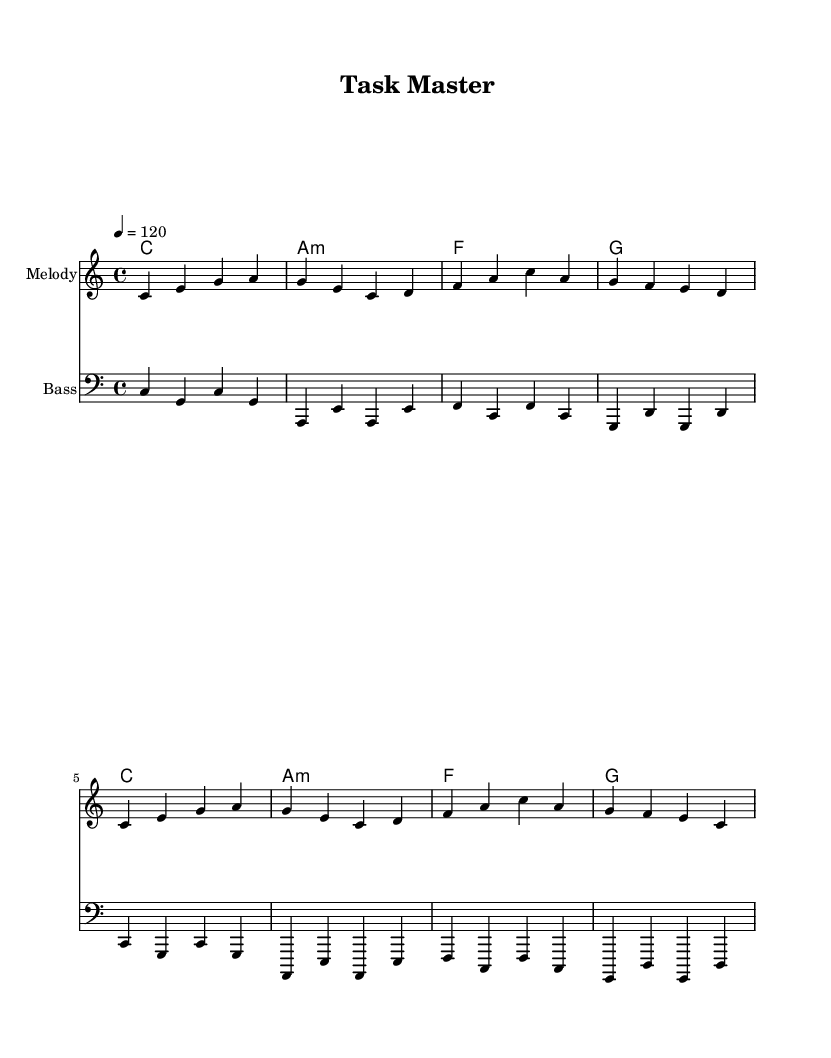What is the key signature of this music? The key signature is C major since there are no sharps or flats indicated. This is identified by looking at the absence of any accidental symbols on the staff.
Answer: C major What is the time signature of this music? The time signature is 4/4, as indicated near the beginning of the score. This tells us there are four beats in each measure and a quarter note receives one beat.
Answer: 4/4 What is the tempo marking for this piece? The tempo marking is 120 beats per minute, indicated as '4 = 120'. This specifies the speed at which the piece should be played.
Answer: 120 How many measures are there in the melody? The melody section contains 8 measures total, which can be counted by looking at how many vertical lines separate the music notation.
Answer: 8 What chord appears most frequently in the harmonies? The C chord is the most frequently occurring chord, showing up at the beginning and again after a series of other chords. We can determine this by noting its repetition in the chord progressions listed.
Answer: C Why is this music categorized as pop? This music has an upbeat tempo, simple melodic lines, and repetitive chord structures, typical characteristics of pop music. Analyzing the melody and harmony reveals a formulaic and catchy style, which is a hallmark of the genre.
Answer: Upbeat, simple 